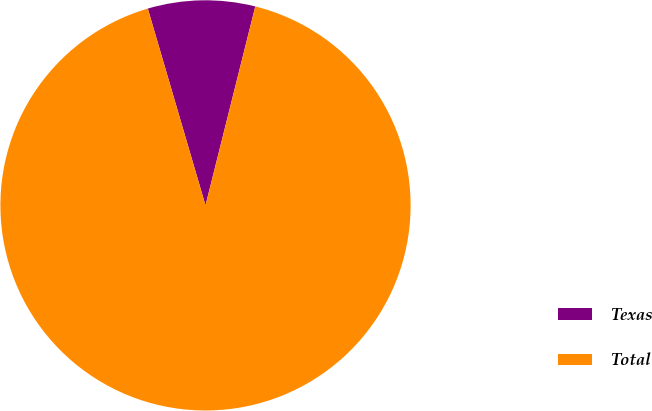Convert chart to OTSL. <chart><loc_0><loc_0><loc_500><loc_500><pie_chart><fcel>Texas<fcel>Total<nl><fcel>8.44%<fcel>91.56%<nl></chart> 